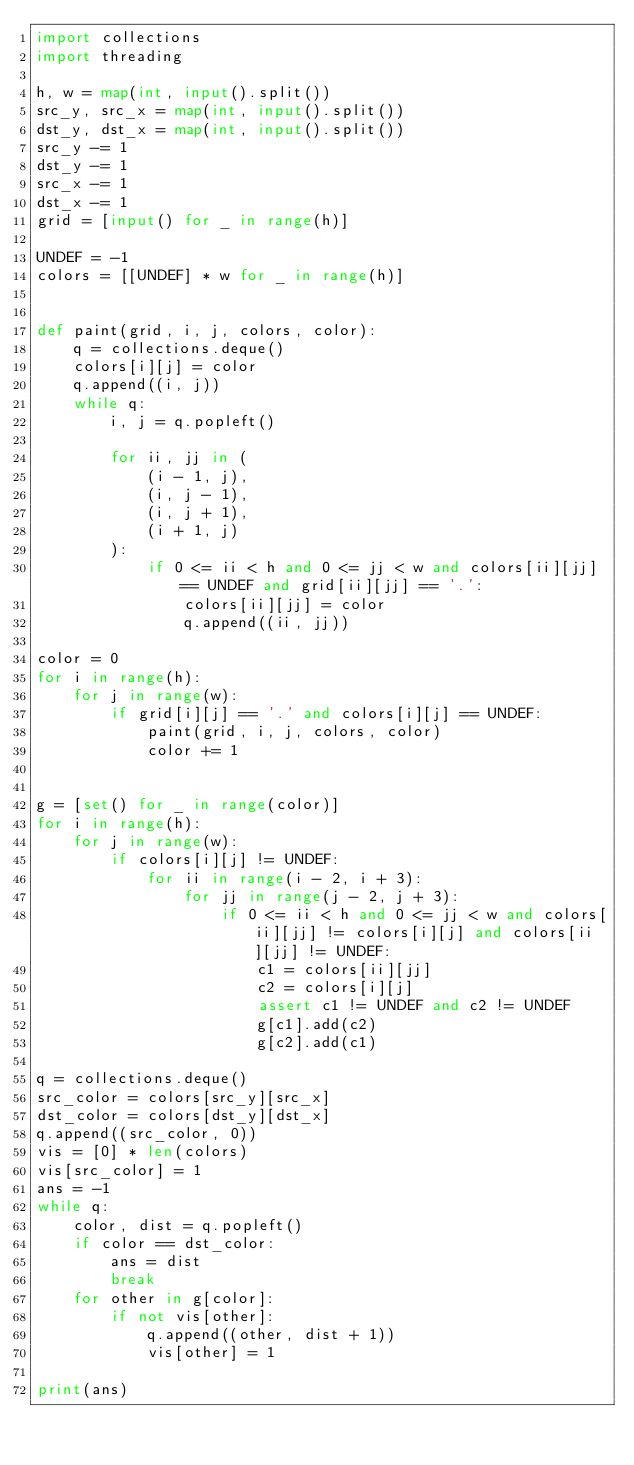Convert code to text. <code><loc_0><loc_0><loc_500><loc_500><_Python_>import collections
import threading

h, w = map(int, input().split())
src_y, src_x = map(int, input().split())
dst_y, dst_x = map(int, input().split())
src_y -= 1
dst_y -= 1
src_x -= 1
dst_x -= 1
grid = [input() for _ in range(h)]

UNDEF = -1
colors = [[UNDEF] * w for _ in range(h)]


def paint(grid, i, j, colors, color):
    q = collections.deque()
    colors[i][j] = color
    q.append((i, j))
    while q:
        i, j = q.popleft()

        for ii, jj in (
            (i - 1, j),
            (i, j - 1),
            (i, j + 1),
            (i + 1, j)
        ):
            if 0 <= ii < h and 0 <= jj < w and colors[ii][jj] == UNDEF and grid[ii][jj] == '.':
                colors[ii][jj] = color
                q.append((ii, jj))

color = 0
for i in range(h):
    for j in range(w):
        if grid[i][j] == '.' and colors[i][j] == UNDEF:
            paint(grid, i, j, colors, color)
            color += 1


g = [set() for _ in range(color)]
for i in range(h):
    for j in range(w):
        if colors[i][j] != UNDEF:
            for ii in range(i - 2, i + 3):
                for jj in range(j - 2, j + 3):
                    if 0 <= ii < h and 0 <= jj < w and colors[ii][jj] != colors[i][j] and colors[ii][jj] != UNDEF:
                        c1 = colors[ii][jj]
                        c2 = colors[i][j]
                        assert c1 != UNDEF and c2 != UNDEF
                        g[c1].add(c2)
                        g[c2].add(c1)

q = collections.deque()
src_color = colors[src_y][src_x]
dst_color = colors[dst_y][dst_x]
q.append((src_color, 0))
vis = [0] * len(colors)
vis[src_color] = 1
ans = -1
while q:
    color, dist = q.popleft()
    if color == dst_color:
        ans = dist
        break
    for other in g[color]:
        if not vis[other]:
            q.append((other, dist + 1))
            vis[other] = 1

print(ans)
</code> 